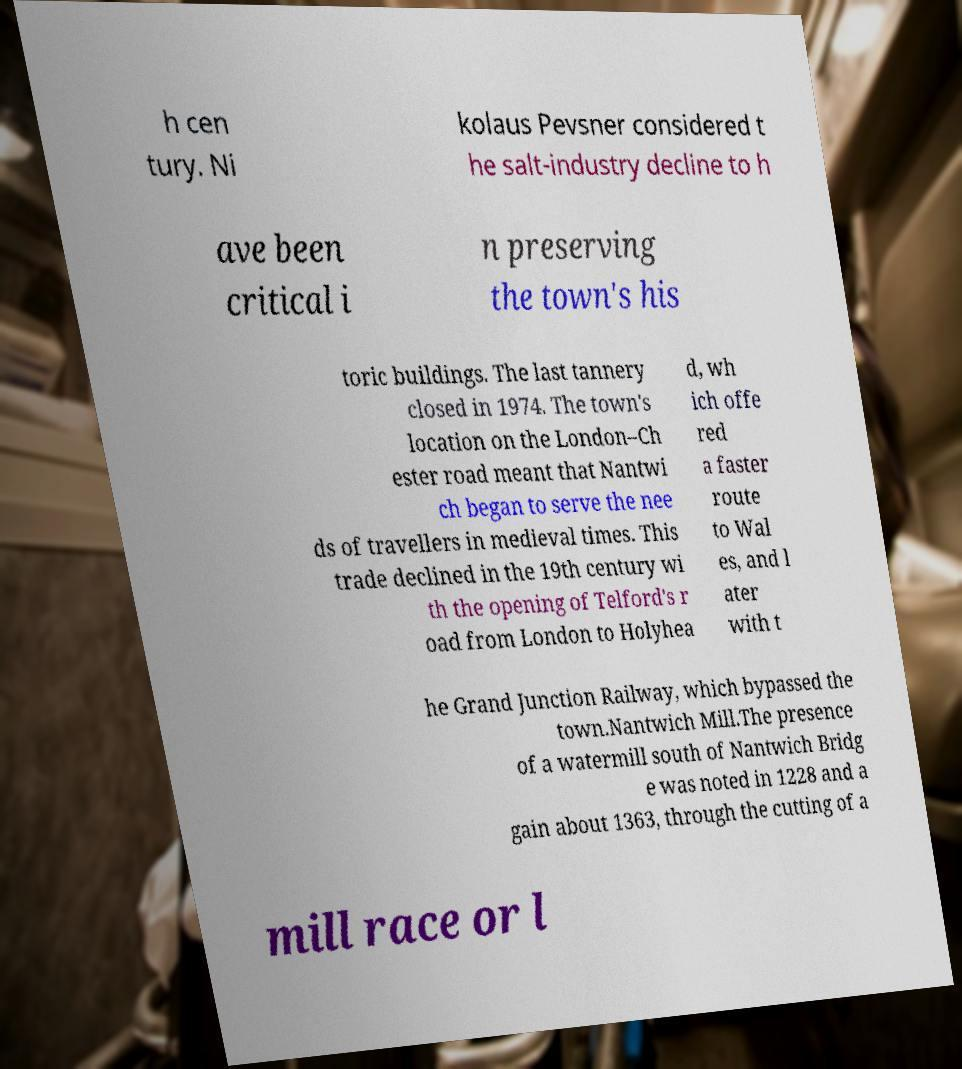Can you read and provide the text displayed in the image?This photo seems to have some interesting text. Can you extract and type it out for me? h cen tury. Ni kolaus Pevsner considered t he salt-industry decline to h ave been critical i n preserving the town's his toric buildings. The last tannery closed in 1974. The town's location on the London–Ch ester road meant that Nantwi ch began to serve the nee ds of travellers in medieval times. This trade declined in the 19th century wi th the opening of Telford's r oad from London to Holyhea d, wh ich offe red a faster route to Wal es, and l ater with t he Grand Junction Railway, which bypassed the town.Nantwich Mill.The presence of a watermill south of Nantwich Bridg e was noted in 1228 and a gain about 1363, through the cutting of a mill race or l 